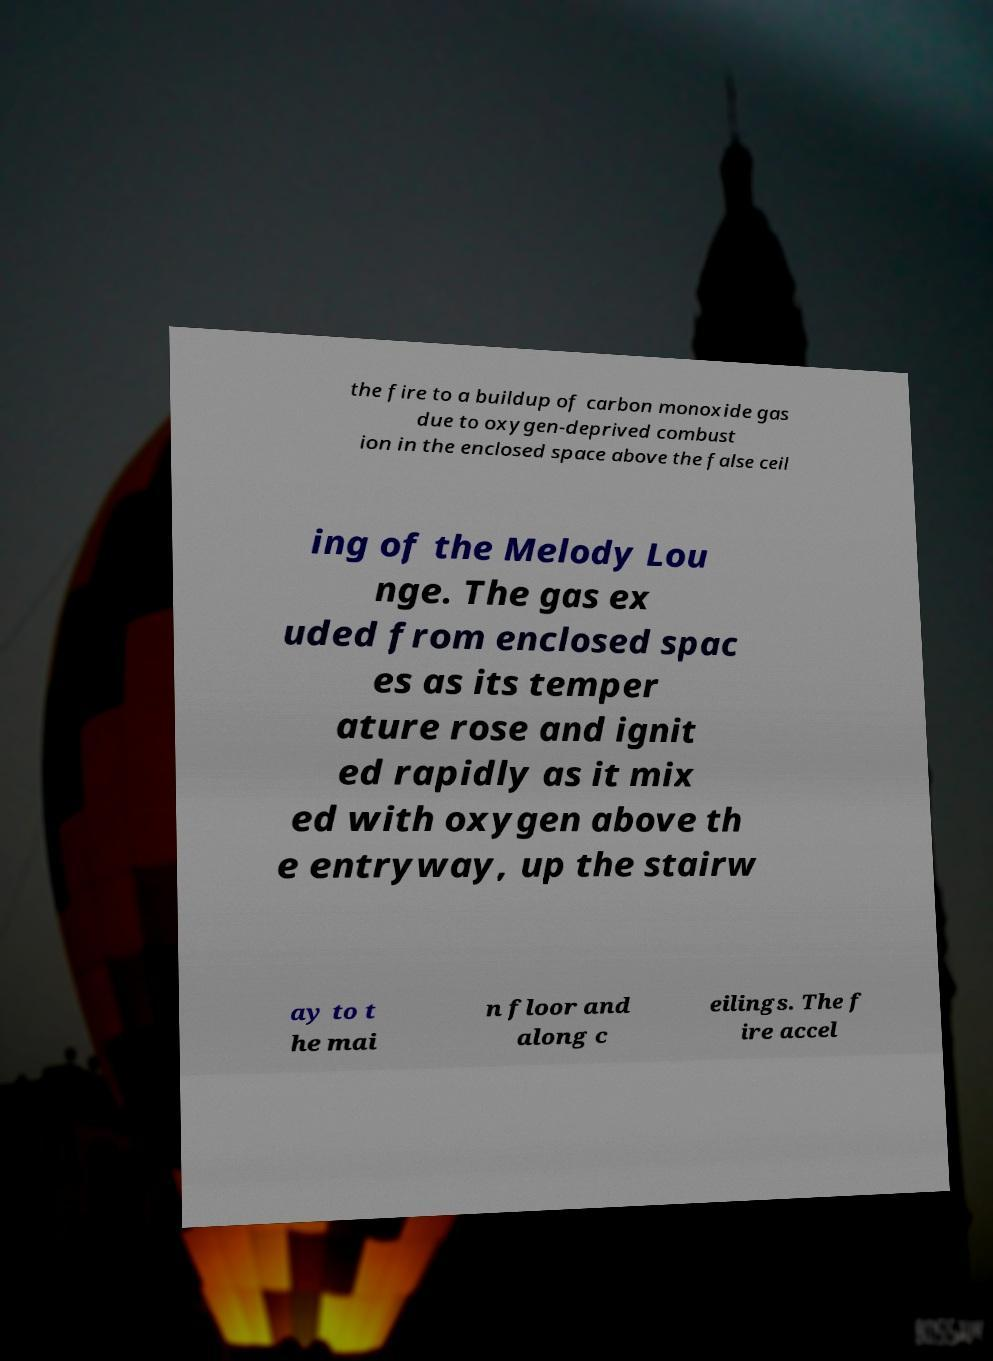Please read and relay the text visible in this image. What does it say? the fire to a buildup of carbon monoxide gas due to oxygen-deprived combust ion in the enclosed space above the false ceil ing of the Melody Lou nge. The gas ex uded from enclosed spac es as its temper ature rose and ignit ed rapidly as it mix ed with oxygen above th e entryway, up the stairw ay to t he mai n floor and along c eilings. The f ire accel 